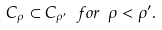Convert formula to latex. <formula><loc_0><loc_0><loc_500><loc_500>C _ { \rho } \subset C _ { \rho ^ { \prime } } \ f o r \ \rho < \rho ^ { \prime } .</formula> 